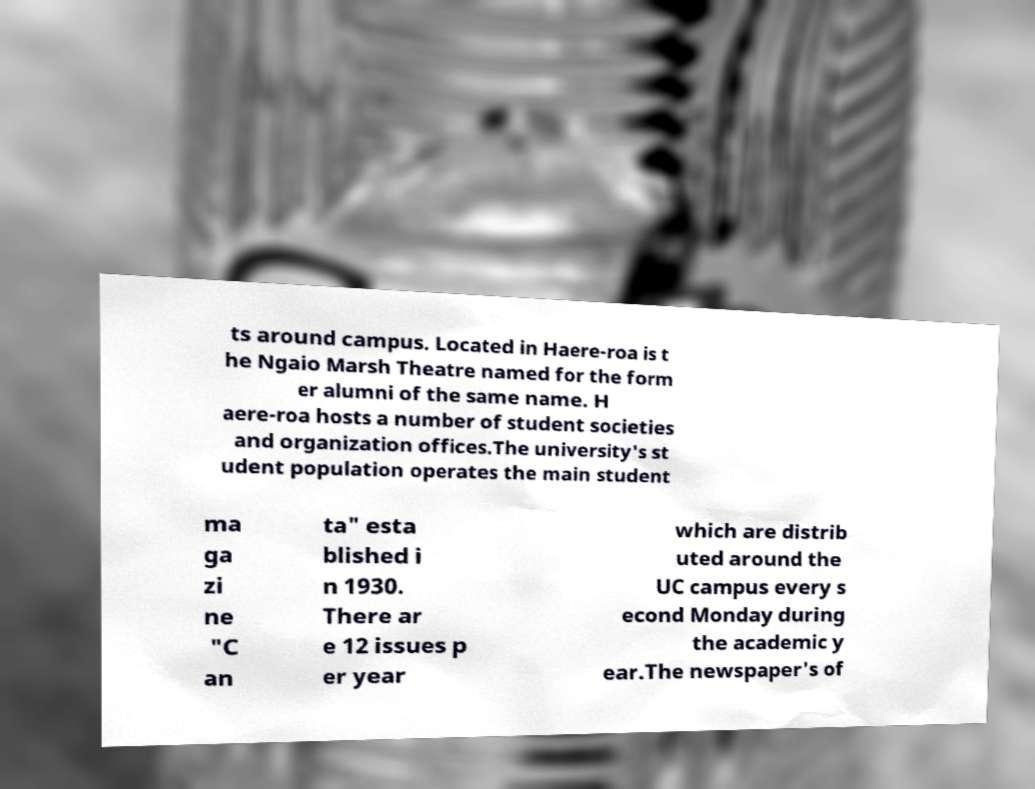Can you accurately transcribe the text from the provided image for me? ts around campus. Located in Haere-roa is t he Ngaio Marsh Theatre named for the form er alumni of the same name. H aere-roa hosts a number of student societies and organization offices.The university's st udent population operates the main student ma ga zi ne "C an ta" esta blished i n 1930. There ar e 12 issues p er year which are distrib uted around the UC campus every s econd Monday during the academic y ear.The newspaper's of 